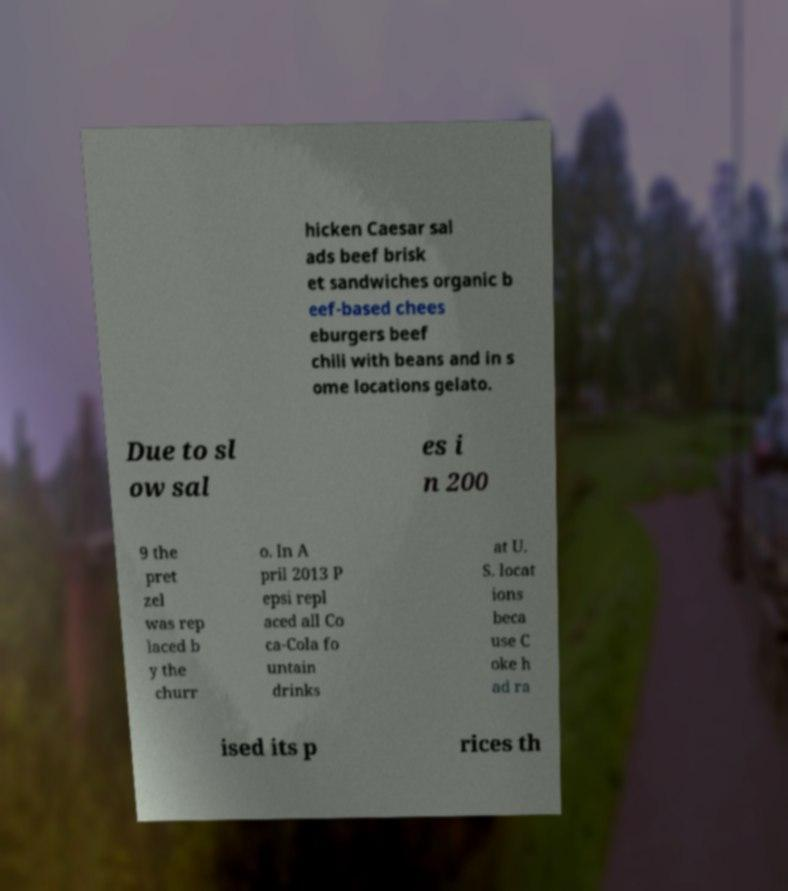Please identify and transcribe the text found in this image. hicken Caesar sal ads beef brisk et sandwiches organic b eef-based chees eburgers beef chili with beans and in s ome locations gelato. Due to sl ow sal es i n 200 9 the pret zel was rep laced b y the churr o. In A pril 2013 P epsi repl aced all Co ca-Cola fo untain drinks at U. S. locat ions beca use C oke h ad ra ised its p rices th 